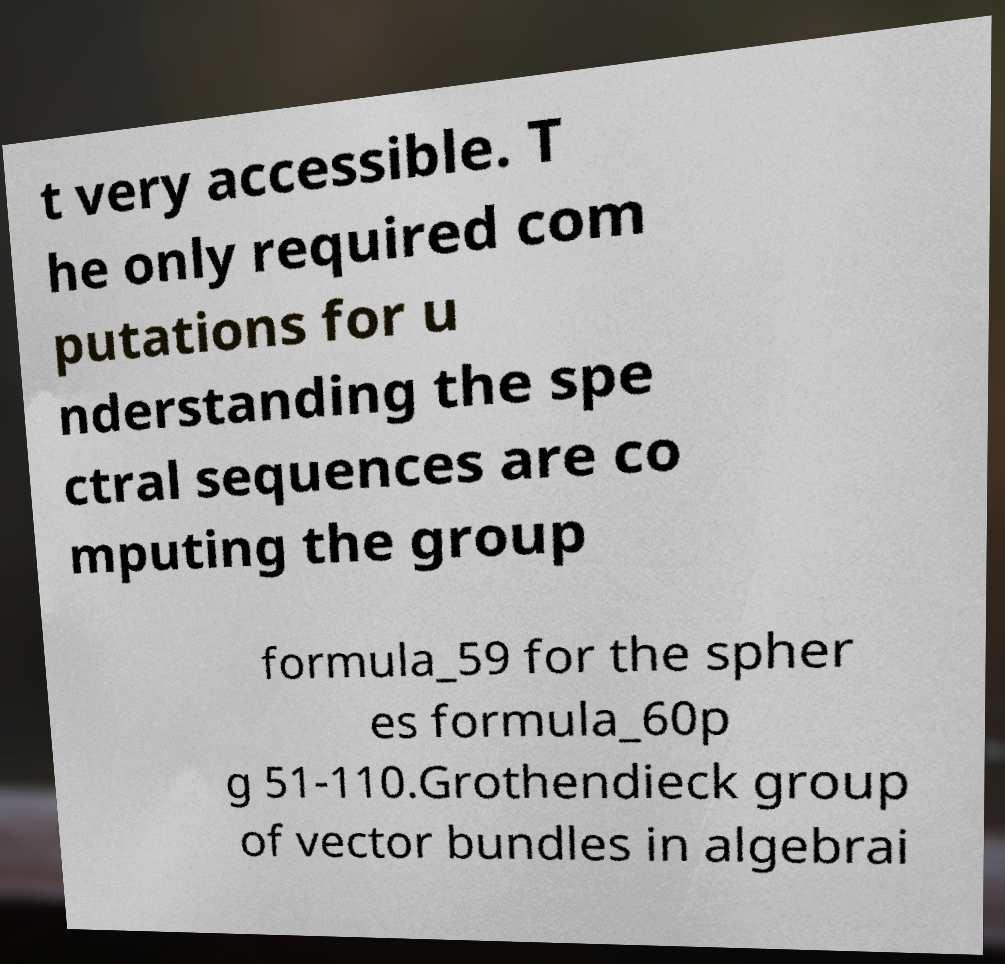What messages or text are displayed in this image? I need them in a readable, typed format. t very accessible. T he only required com putations for u nderstanding the spe ctral sequences are co mputing the group formula_59 for the spher es formula_60p g 51-110.Grothendieck group of vector bundles in algebrai 